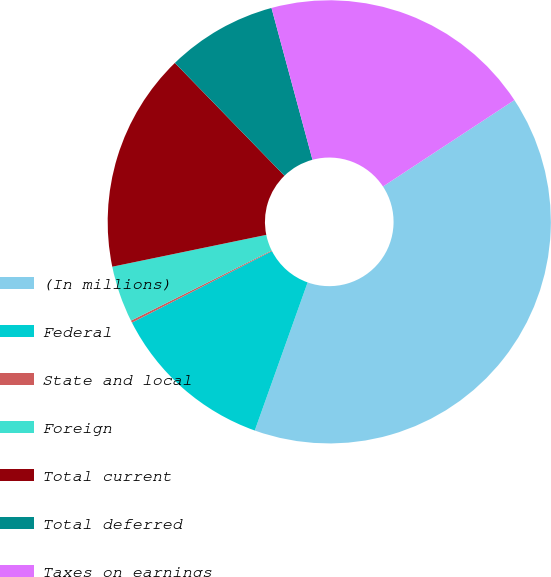<chart> <loc_0><loc_0><loc_500><loc_500><pie_chart><fcel>(In millions)<fcel>Federal<fcel>State and local<fcel>Foreign<fcel>Total current<fcel>Total deferred<fcel>Taxes on earnings<nl><fcel>39.72%<fcel>12.03%<fcel>0.16%<fcel>4.11%<fcel>15.98%<fcel>8.07%<fcel>19.94%<nl></chart> 